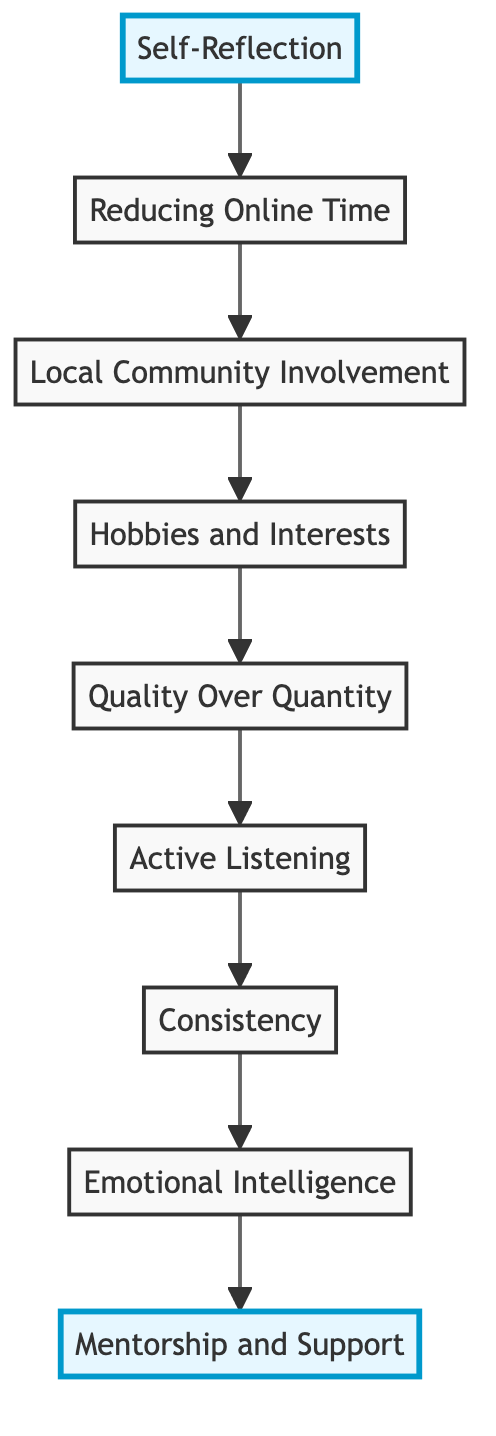What is the top node in the diagram? The diagram's top node is the last element of the flow which represents the pinnacle of the progression towards building healthy offline social networks. It is labeled "Mentorship and Support."
Answer: Mentorship and Support How many nodes are in the diagram? The flow chart contains nine nodes, each representing a step in the development of healthy offline social networks.
Answer: 9 What is the relationship between "Active Listening" and "Consistency"? "Active Listening" is followed by "Consistency" in the flow chart, indicating that improving communication skills through active listening leads to the need for consistency in maintaining relationships.
Answer: Active Listening → Consistency Which node directly connects to "Reducing Online Time"? The node directly connected above "Reducing Online Time" is "Self-Reflection," indicating that self-reflection is a prerequisite for reducing online time.
Answer: Self-Reflection What is the path from "Self-Reflection" to "Hobbies and Interests"? The path starts from "Self-Reflection," then moves to "Reducing Online Time," continues to "Local Community Involvement," and finally leads to "Hobbies and Interests," showing the steps necessary to engage in activities related to hobbies.
Answer: Self-Reflection → Reducing Online Time → Local Community Involvement → Hobbies and Interests How do "Quality Over Quantity" and "Emotional Intelligence" relate to each other in the diagram? "Quality Over Quantity" leads into "Active Listening," which then leads to "Consistency," followed by "Emotional Intelligence." The connection shows that building quality relationships prepares one for understanding emotions effectively.
Answer: Quality Over Quantity → Active Listening → Consistency → Emotional Intelligence What step comes after "Local Community Involvement"? The next step after "Local Community Involvement" in the progression is "Hobbies and Interests," showing how community participation leads to involvement in personal interests.
Answer: Hobbies and Interests Which element highlights the importance of understanding emotions? The element titled "Emotional Intelligence" emphasizes understanding and managing emotions, along with empathizing with others, which is crucial for building healthy social networks.
Answer: Emotional Intelligence What does the diagram suggest is more important: quantity or quality of social interactions? The diagram emphasizes "Quality Over Quantity," indicating that the focus should be on building meaningful relationships rather than numerous shallow connections.
Answer: Quality Over Quantity 